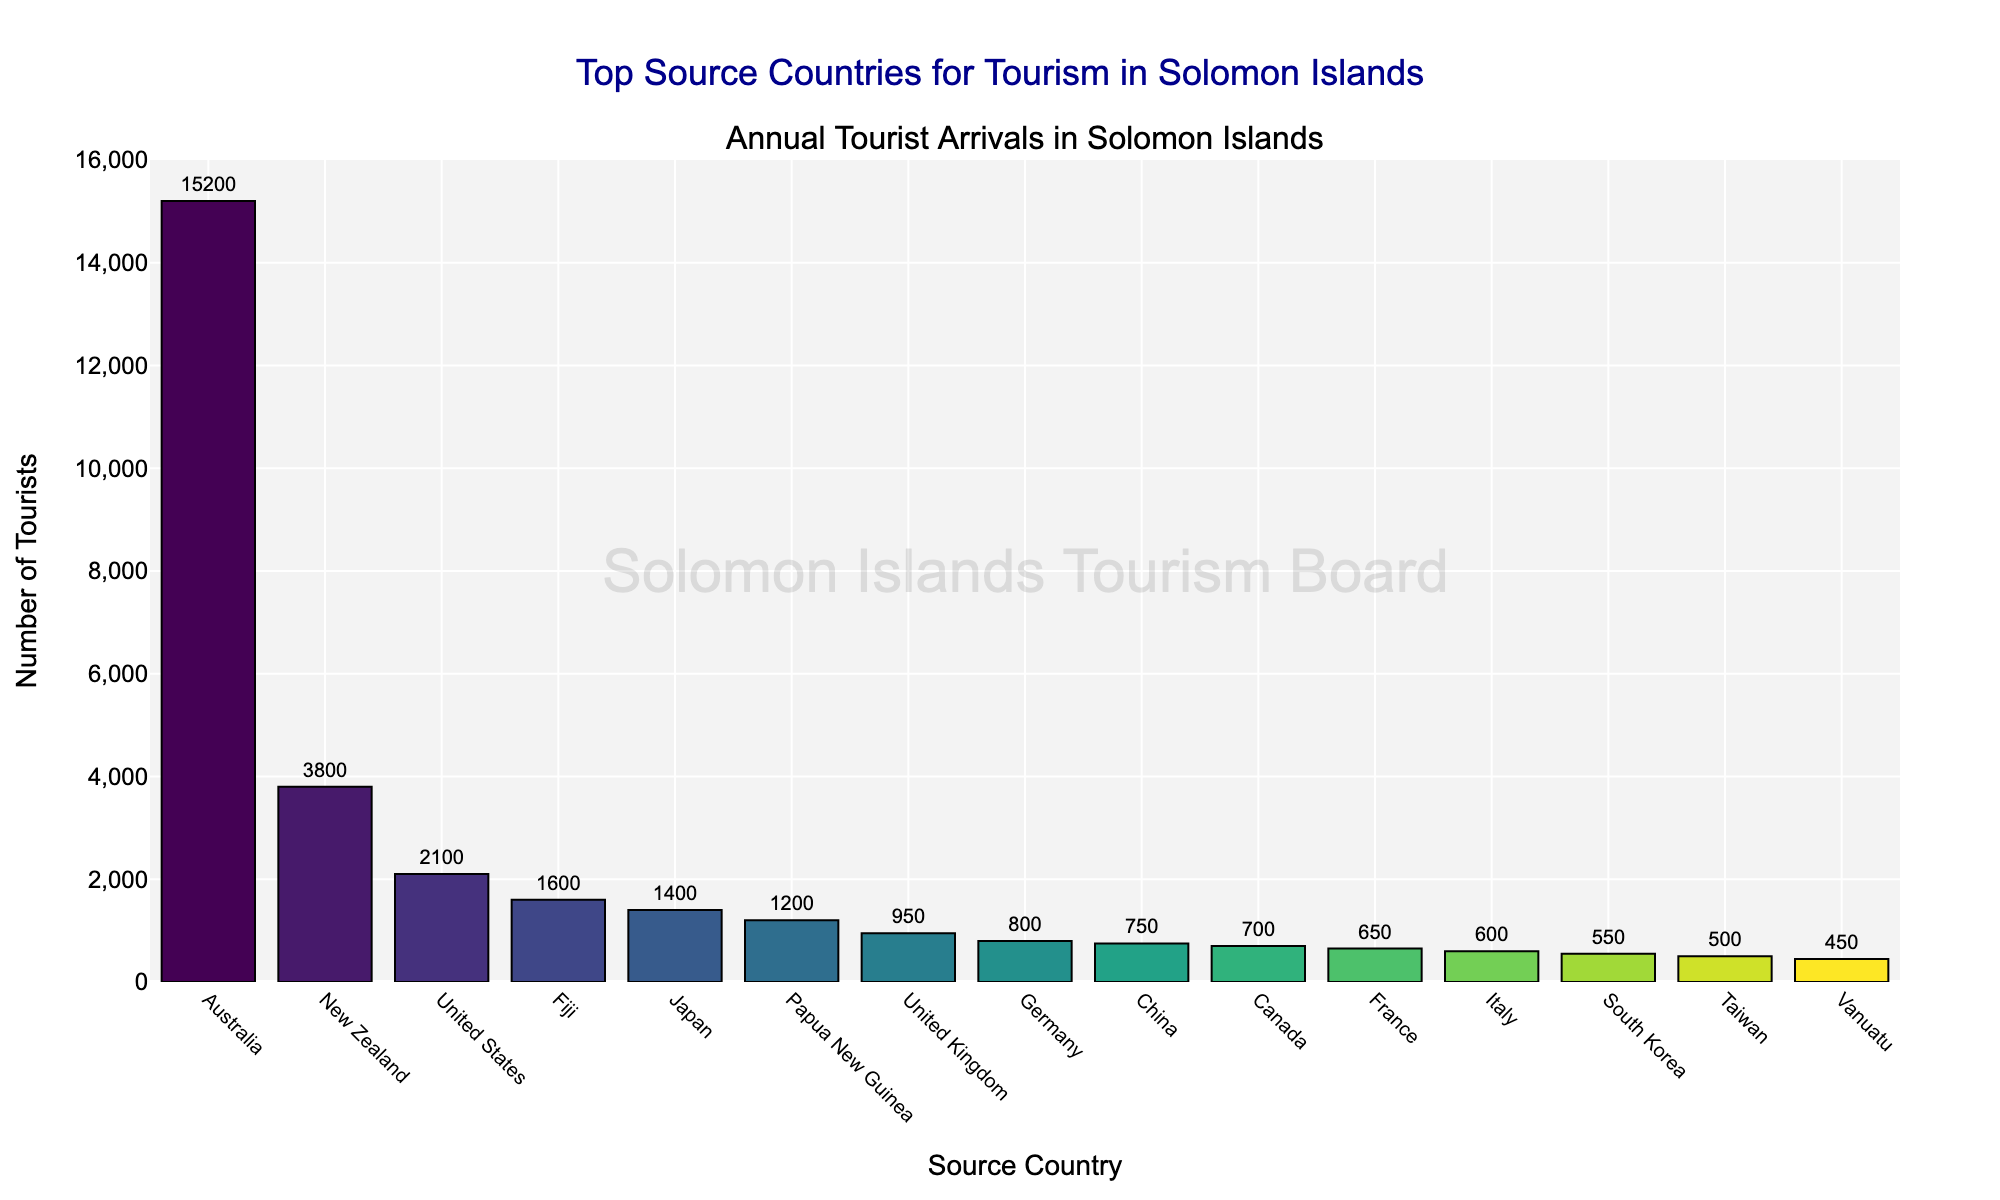Which country has the highest number of tourist arrivals? The figure shows annual tourist arrivals in descending order, with Australia at the top, indicating it has the highest number of tourist arrivals.
Answer: Australia What is the combined total of tourist arrivals from Australia, New Zealand, and the United States? The chart provides the number of tourist arrivals from each country. Adding the values for Australia (15,200), New Zealand (3,800), and the United States (2,100) gives 15,200 + 3,800 + 2,100 = 21,100.
Answer: 21,100 Which country has fewer tourist arrivals: Japan or Fiji? By comparing the heights of the bars for Japan and Fiji, the figure shows Japan with 1,400 tourist arrivals and Fiji with 1,600 tourist arrivals, indicating Japan has fewer arrivals.
Answer: Japan How many more tourists does Australia receive compared to Papua New Guinea? Subtract the number of tourist arrivals for Papua New Guinea (1,200) from that for Australia (15,200) gives 15,200 - 1,200 = 14,000.
Answer: 14,000 What is the total number of tourist arrivals from countries with fewer than 1,000 tourists? Adding the values for the countries with fewer than 1,000 tourists: United Kingdom (950), Germany (800), China (750), Canada (700), France (650), Italy (600), South Korea (550), Taiwan (500), Vanuatu (450) gives a total of 950 + 800 + 750 + 700 + 650 + 600 + 550 + 500 + 450 = 5,950.
Answer: 5,950 Which three countries have the lowest number of tourist arrivals? The chart shows the tourist arrivals in descending order. The three countries with the shortest bars, indicating the fewest arrivals, are Vanuatu (450), Taiwan (500), and South Korea (550).
Answer: Vanuatu, Taiwan, and South Korea Between Canada and Germany, which country receives more tourists, and by how much? Comparing the bars for Canada (700) and Germany (800), Germany has more tourists. The difference is 800 - 700 = 100.
Answer: Germany by 100 What is the average number of tourists arriving from the top five source countries? Adding the number of tourists from the top five countries: Australia (15,200), New Zealand (3,800), United States (2,100), Fiji (1,600), and Japan (1,400) gives 15,200 + 3,800 + 2,100 + 1,600 + 1,400 = 24,100. The average is 24,100 / 5 = 4,820.
Answer: 4,820 